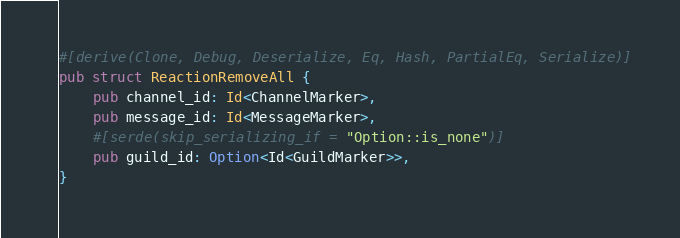<code> <loc_0><loc_0><loc_500><loc_500><_Rust_>#[derive(Clone, Debug, Deserialize, Eq, Hash, PartialEq, Serialize)]
pub struct ReactionRemoveAll {
    pub channel_id: Id<ChannelMarker>,
    pub message_id: Id<MessageMarker>,
    #[serde(skip_serializing_if = "Option::is_none")]
    pub guild_id: Option<Id<GuildMarker>>,
}
</code> 